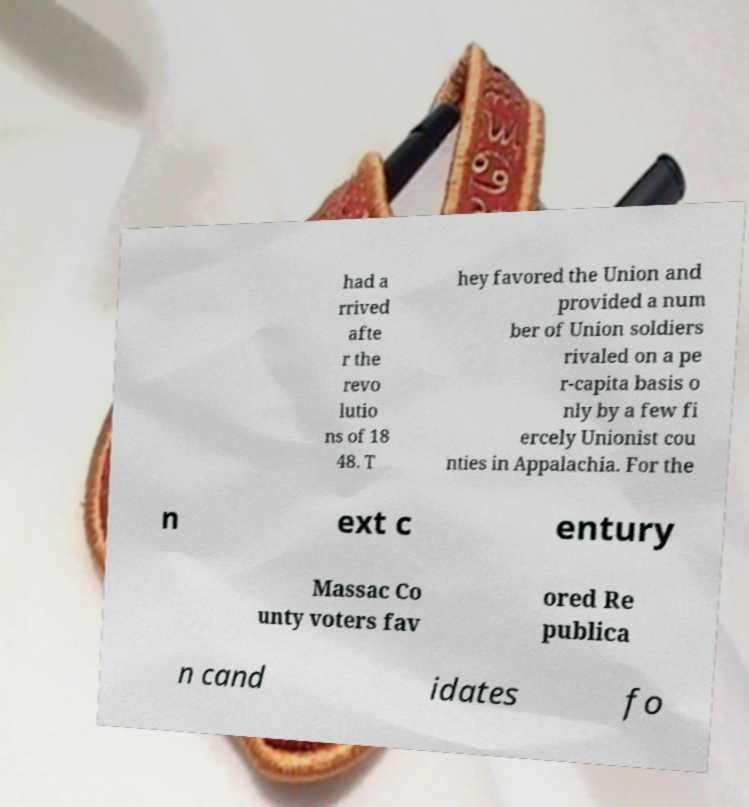For documentation purposes, I need the text within this image transcribed. Could you provide that? had a rrived afte r the revo lutio ns of 18 48. T hey favored the Union and provided a num ber of Union soldiers rivaled on a pe r-capita basis o nly by a few fi ercely Unionist cou nties in Appalachia. For the n ext c entury Massac Co unty voters fav ored Re publica n cand idates fo 